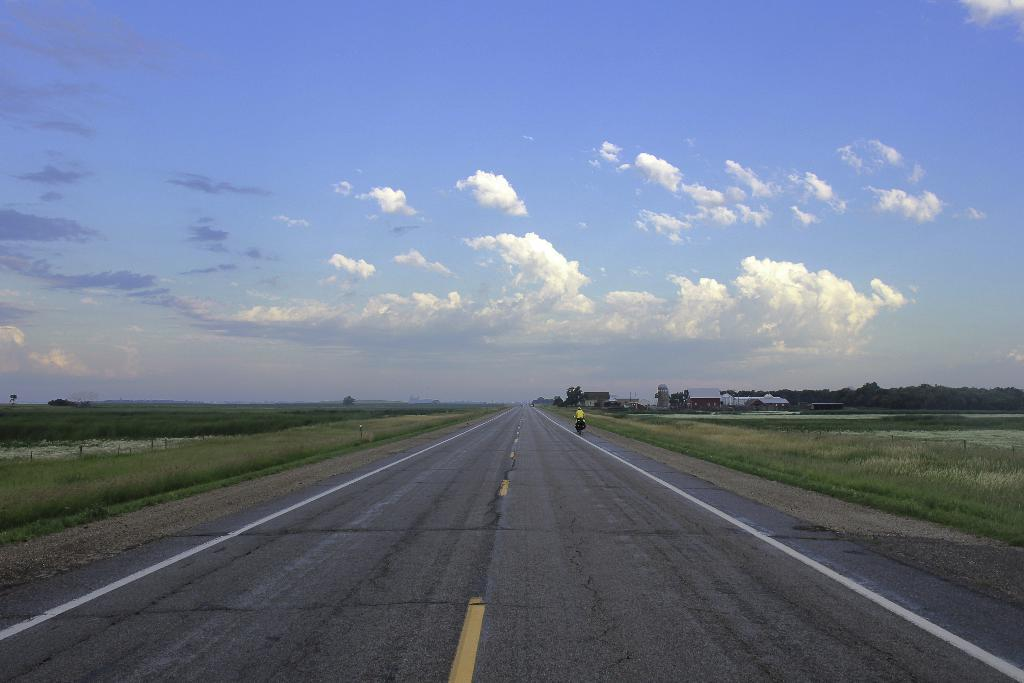What is the main feature of the image? There is a road in the image. What can be seen on both sides of the road? There is grass on both sides of the road. What is happening on the road? A person is riding a vehicle on the road. What can be seen in the background of the image? There are buildings, trees, and the sky visible in the background of the image. What type of dirt is visible on the frame of the vehicle in the image? There is no dirt visible on the frame of the vehicle in the image, and there is no mention of a frame in the provided facts. How does the person riding the vehicle apply the brake in the image? There is no information about the person applying the brake in the image, as the focus is on the person riding the vehicle. 